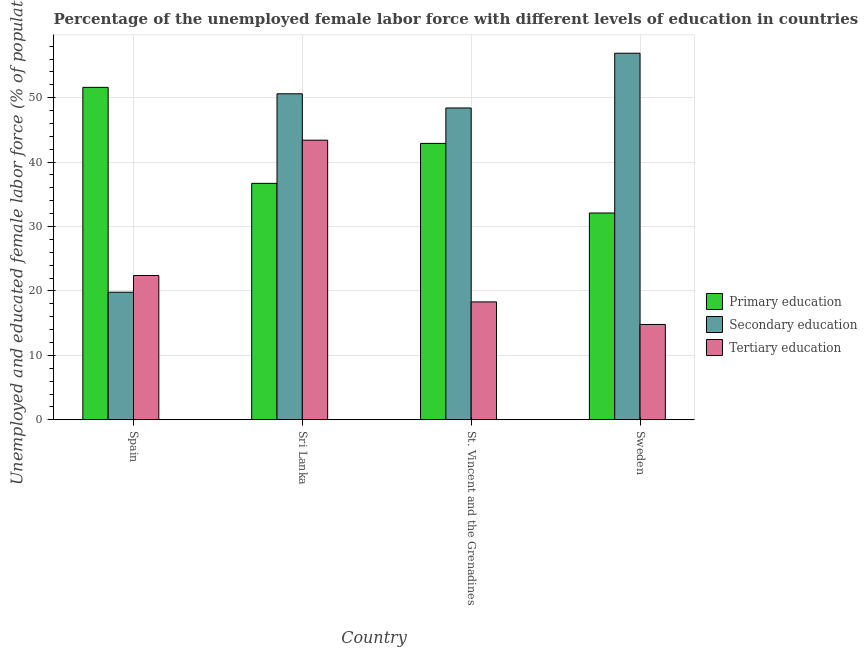How many different coloured bars are there?
Your answer should be compact. 3. Are the number of bars per tick equal to the number of legend labels?
Make the answer very short. Yes. Are the number of bars on each tick of the X-axis equal?
Provide a succinct answer. Yes. How many bars are there on the 2nd tick from the right?
Your response must be concise. 3. What is the label of the 4th group of bars from the left?
Give a very brief answer. Sweden. In how many cases, is the number of bars for a given country not equal to the number of legend labels?
Your answer should be compact. 0. What is the percentage of female labor force who received secondary education in Sweden?
Offer a very short reply. 56.9. Across all countries, what is the maximum percentage of female labor force who received primary education?
Your answer should be very brief. 51.6. Across all countries, what is the minimum percentage of female labor force who received tertiary education?
Offer a terse response. 14.8. In which country was the percentage of female labor force who received primary education maximum?
Give a very brief answer. Spain. What is the total percentage of female labor force who received secondary education in the graph?
Make the answer very short. 175.7. What is the difference between the percentage of female labor force who received primary education in Spain and that in Sri Lanka?
Keep it short and to the point. 14.9. What is the difference between the percentage of female labor force who received secondary education in St. Vincent and the Grenadines and the percentage of female labor force who received primary education in Sweden?
Provide a succinct answer. 16.3. What is the average percentage of female labor force who received tertiary education per country?
Ensure brevity in your answer.  24.73. What is the difference between the percentage of female labor force who received tertiary education and percentage of female labor force who received secondary education in Spain?
Your response must be concise. 2.6. In how many countries, is the percentage of female labor force who received secondary education greater than 34 %?
Keep it short and to the point. 3. What is the ratio of the percentage of female labor force who received primary education in Spain to that in Sweden?
Offer a very short reply. 1.61. What is the difference between the highest and the second highest percentage of female labor force who received primary education?
Ensure brevity in your answer.  8.7. What is the difference between the highest and the lowest percentage of female labor force who received tertiary education?
Offer a terse response. 28.6. Is the sum of the percentage of female labor force who received tertiary education in Spain and St. Vincent and the Grenadines greater than the maximum percentage of female labor force who received primary education across all countries?
Provide a short and direct response. No. What does the 2nd bar from the left in Sweden represents?
Offer a terse response. Secondary education. What does the 3rd bar from the right in Sri Lanka represents?
Make the answer very short. Primary education. How many bars are there?
Offer a terse response. 12. Are all the bars in the graph horizontal?
Your answer should be compact. No. Are the values on the major ticks of Y-axis written in scientific E-notation?
Make the answer very short. No. Does the graph contain any zero values?
Your response must be concise. No. Does the graph contain grids?
Your response must be concise. Yes. How many legend labels are there?
Your response must be concise. 3. How are the legend labels stacked?
Keep it short and to the point. Vertical. What is the title of the graph?
Your answer should be very brief. Percentage of the unemployed female labor force with different levels of education in countries. What is the label or title of the Y-axis?
Ensure brevity in your answer.  Unemployed and educated female labor force (% of population). What is the Unemployed and educated female labor force (% of population) in Primary education in Spain?
Offer a very short reply. 51.6. What is the Unemployed and educated female labor force (% of population) of Secondary education in Spain?
Keep it short and to the point. 19.8. What is the Unemployed and educated female labor force (% of population) in Tertiary education in Spain?
Your response must be concise. 22.4. What is the Unemployed and educated female labor force (% of population) of Primary education in Sri Lanka?
Keep it short and to the point. 36.7. What is the Unemployed and educated female labor force (% of population) of Secondary education in Sri Lanka?
Keep it short and to the point. 50.6. What is the Unemployed and educated female labor force (% of population) of Tertiary education in Sri Lanka?
Provide a succinct answer. 43.4. What is the Unemployed and educated female labor force (% of population) in Primary education in St. Vincent and the Grenadines?
Your answer should be compact. 42.9. What is the Unemployed and educated female labor force (% of population) in Secondary education in St. Vincent and the Grenadines?
Provide a succinct answer. 48.4. What is the Unemployed and educated female labor force (% of population) of Tertiary education in St. Vincent and the Grenadines?
Ensure brevity in your answer.  18.3. What is the Unemployed and educated female labor force (% of population) of Primary education in Sweden?
Keep it short and to the point. 32.1. What is the Unemployed and educated female labor force (% of population) in Secondary education in Sweden?
Your response must be concise. 56.9. What is the Unemployed and educated female labor force (% of population) in Tertiary education in Sweden?
Your answer should be very brief. 14.8. Across all countries, what is the maximum Unemployed and educated female labor force (% of population) of Primary education?
Keep it short and to the point. 51.6. Across all countries, what is the maximum Unemployed and educated female labor force (% of population) of Secondary education?
Provide a succinct answer. 56.9. Across all countries, what is the maximum Unemployed and educated female labor force (% of population) of Tertiary education?
Ensure brevity in your answer.  43.4. Across all countries, what is the minimum Unemployed and educated female labor force (% of population) of Primary education?
Give a very brief answer. 32.1. Across all countries, what is the minimum Unemployed and educated female labor force (% of population) of Secondary education?
Give a very brief answer. 19.8. Across all countries, what is the minimum Unemployed and educated female labor force (% of population) in Tertiary education?
Your answer should be compact. 14.8. What is the total Unemployed and educated female labor force (% of population) of Primary education in the graph?
Your answer should be compact. 163.3. What is the total Unemployed and educated female labor force (% of population) of Secondary education in the graph?
Your answer should be compact. 175.7. What is the total Unemployed and educated female labor force (% of population) of Tertiary education in the graph?
Provide a succinct answer. 98.9. What is the difference between the Unemployed and educated female labor force (% of population) in Secondary education in Spain and that in Sri Lanka?
Provide a succinct answer. -30.8. What is the difference between the Unemployed and educated female labor force (% of population) in Tertiary education in Spain and that in Sri Lanka?
Your answer should be very brief. -21. What is the difference between the Unemployed and educated female labor force (% of population) in Secondary education in Spain and that in St. Vincent and the Grenadines?
Ensure brevity in your answer.  -28.6. What is the difference between the Unemployed and educated female labor force (% of population) of Tertiary education in Spain and that in St. Vincent and the Grenadines?
Keep it short and to the point. 4.1. What is the difference between the Unemployed and educated female labor force (% of population) in Primary education in Spain and that in Sweden?
Provide a succinct answer. 19.5. What is the difference between the Unemployed and educated female labor force (% of population) in Secondary education in Spain and that in Sweden?
Your answer should be compact. -37.1. What is the difference between the Unemployed and educated female labor force (% of population) in Primary education in Sri Lanka and that in St. Vincent and the Grenadines?
Make the answer very short. -6.2. What is the difference between the Unemployed and educated female labor force (% of population) of Tertiary education in Sri Lanka and that in St. Vincent and the Grenadines?
Your answer should be compact. 25.1. What is the difference between the Unemployed and educated female labor force (% of population) in Tertiary education in Sri Lanka and that in Sweden?
Provide a short and direct response. 28.6. What is the difference between the Unemployed and educated female labor force (% of population) of Secondary education in Spain and the Unemployed and educated female labor force (% of population) of Tertiary education in Sri Lanka?
Give a very brief answer. -23.6. What is the difference between the Unemployed and educated female labor force (% of population) of Primary education in Spain and the Unemployed and educated female labor force (% of population) of Tertiary education in St. Vincent and the Grenadines?
Your answer should be compact. 33.3. What is the difference between the Unemployed and educated female labor force (% of population) in Secondary education in Spain and the Unemployed and educated female labor force (% of population) in Tertiary education in St. Vincent and the Grenadines?
Provide a short and direct response. 1.5. What is the difference between the Unemployed and educated female labor force (% of population) of Primary education in Spain and the Unemployed and educated female labor force (% of population) of Tertiary education in Sweden?
Give a very brief answer. 36.8. What is the difference between the Unemployed and educated female labor force (% of population) of Primary education in Sri Lanka and the Unemployed and educated female labor force (% of population) of Secondary education in St. Vincent and the Grenadines?
Provide a succinct answer. -11.7. What is the difference between the Unemployed and educated female labor force (% of population) in Primary education in Sri Lanka and the Unemployed and educated female labor force (% of population) in Tertiary education in St. Vincent and the Grenadines?
Offer a terse response. 18.4. What is the difference between the Unemployed and educated female labor force (% of population) of Secondary education in Sri Lanka and the Unemployed and educated female labor force (% of population) of Tertiary education in St. Vincent and the Grenadines?
Offer a very short reply. 32.3. What is the difference between the Unemployed and educated female labor force (% of population) in Primary education in Sri Lanka and the Unemployed and educated female labor force (% of population) in Secondary education in Sweden?
Ensure brevity in your answer.  -20.2. What is the difference between the Unemployed and educated female labor force (% of population) in Primary education in Sri Lanka and the Unemployed and educated female labor force (% of population) in Tertiary education in Sweden?
Provide a succinct answer. 21.9. What is the difference between the Unemployed and educated female labor force (% of population) of Secondary education in Sri Lanka and the Unemployed and educated female labor force (% of population) of Tertiary education in Sweden?
Provide a short and direct response. 35.8. What is the difference between the Unemployed and educated female labor force (% of population) of Primary education in St. Vincent and the Grenadines and the Unemployed and educated female labor force (% of population) of Secondary education in Sweden?
Your answer should be very brief. -14. What is the difference between the Unemployed and educated female labor force (% of population) in Primary education in St. Vincent and the Grenadines and the Unemployed and educated female labor force (% of population) in Tertiary education in Sweden?
Ensure brevity in your answer.  28.1. What is the difference between the Unemployed and educated female labor force (% of population) in Secondary education in St. Vincent and the Grenadines and the Unemployed and educated female labor force (% of population) in Tertiary education in Sweden?
Offer a terse response. 33.6. What is the average Unemployed and educated female labor force (% of population) in Primary education per country?
Give a very brief answer. 40.83. What is the average Unemployed and educated female labor force (% of population) in Secondary education per country?
Your answer should be very brief. 43.92. What is the average Unemployed and educated female labor force (% of population) in Tertiary education per country?
Offer a very short reply. 24.73. What is the difference between the Unemployed and educated female labor force (% of population) in Primary education and Unemployed and educated female labor force (% of population) in Secondary education in Spain?
Give a very brief answer. 31.8. What is the difference between the Unemployed and educated female labor force (% of population) of Primary education and Unemployed and educated female labor force (% of population) of Tertiary education in Spain?
Offer a very short reply. 29.2. What is the difference between the Unemployed and educated female labor force (% of population) of Primary education and Unemployed and educated female labor force (% of population) of Secondary education in Sri Lanka?
Keep it short and to the point. -13.9. What is the difference between the Unemployed and educated female labor force (% of population) in Primary education and Unemployed and educated female labor force (% of population) in Tertiary education in Sri Lanka?
Ensure brevity in your answer.  -6.7. What is the difference between the Unemployed and educated female labor force (% of population) in Primary education and Unemployed and educated female labor force (% of population) in Secondary education in St. Vincent and the Grenadines?
Your answer should be very brief. -5.5. What is the difference between the Unemployed and educated female labor force (% of population) of Primary education and Unemployed and educated female labor force (% of population) of Tertiary education in St. Vincent and the Grenadines?
Provide a short and direct response. 24.6. What is the difference between the Unemployed and educated female labor force (% of population) of Secondary education and Unemployed and educated female labor force (% of population) of Tertiary education in St. Vincent and the Grenadines?
Offer a very short reply. 30.1. What is the difference between the Unemployed and educated female labor force (% of population) of Primary education and Unemployed and educated female labor force (% of population) of Secondary education in Sweden?
Provide a short and direct response. -24.8. What is the difference between the Unemployed and educated female labor force (% of population) in Primary education and Unemployed and educated female labor force (% of population) in Tertiary education in Sweden?
Give a very brief answer. 17.3. What is the difference between the Unemployed and educated female labor force (% of population) in Secondary education and Unemployed and educated female labor force (% of population) in Tertiary education in Sweden?
Keep it short and to the point. 42.1. What is the ratio of the Unemployed and educated female labor force (% of population) in Primary education in Spain to that in Sri Lanka?
Offer a very short reply. 1.41. What is the ratio of the Unemployed and educated female labor force (% of population) of Secondary education in Spain to that in Sri Lanka?
Provide a succinct answer. 0.39. What is the ratio of the Unemployed and educated female labor force (% of population) of Tertiary education in Spain to that in Sri Lanka?
Offer a very short reply. 0.52. What is the ratio of the Unemployed and educated female labor force (% of population) in Primary education in Spain to that in St. Vincent and the Grenadines?
Your answer should be compact. 1.2. What is the ratio of the Unemployed and educated female labor force (% of population) in Secondary education in Spain to that in St. Vincent and the Grenadines?
Your response must be concise. 0.41. What is the ratio of the Unemployed and educated female labor force (% of population) of Tertiary education in Spain to that in St. Vincent and the Grenadines?
Keep it short and to the point. 1.22. What is the ratio of the Unemployed and educated female labor force (% of population) in Primary education in Spain to that in Sweden?
Provide a short and direct response. 1.61. What is the ratio of the Unemployed and educated female labor force (% of population) in Secondary education in Spain to that in Sweden?
Keep it short and to the point. 0.35. What is the ratio of the Unemployed and educated female labor force (% of population) in Tertiary education in Spain to that in Sweden?
Provide a succinct answer. 1.51. What is the ratio of the Unemployed and educated female labor force (% of population) of Primary education in Sri Lanka to that in St. Vincent and the Grenadines?
Keep it short and to the point. 0.86. What is the ratio of the Unemployed and educated female labor force (% of population) of Secondary education in Sri Lanka to that in St. Vincent and the Grenadines?
Your answer should be very brief. 1.05. What is the ratio of the Unemployed and educated female labor force (% of population) in Tertiary education in Sri Lanka to that in St. Vincent and the Grenadines?
Keep it short and to the point. 2.37. What is the ratio of the Unemployed and educated female labor force (% of population) of Primary education in Sri Lanka to that in Sweden?
Offer a terse response. 1.14. What is the ratio of the Unemployed and educated female labor force (% of population) in Secondary education in Sri Lanka to that in Sweden?
Give a very brief answer. 0.89. What is the ratio of the Unemployed and educated female labor force (% of population) in Tertiary education in Sri Lanka to that in Sweden?
Offer a very short reply. 2.93. What is the ratio of the Unemployed and educated female labor force (% of population) of Primary education in St. Vincent and the Grenadines to that in Sweden?
Make the answer very short. 1.34. What is the ratio of the Unemployed and educated female labor force (% of population) in Secondary education in St. Vincent and the Grenadines to that in Sweden?
Your answer should be compact. 0.85. What is the ratio of the Unemployed and educated female labor force (% of population) of Tertiary education in St. Vincent and the Grenadines to that in Sweden?
Your answer should be very brief. 1.24. What is the difference between the highest and the second highest Unemployed and educated female labor force (% of population) of Secondary education?
Your answer should be very brief. 6.3. What is the difference between the highest and the lowest Unemployed and educated female labor force (% of population) in Secondary education?
Provide a short and direct response. 37.1. What is the difference between the highest and the lowest Unemployed and educated female labor force (% of population) of Tertiary education?
Give a very brief answer. 28.6. 